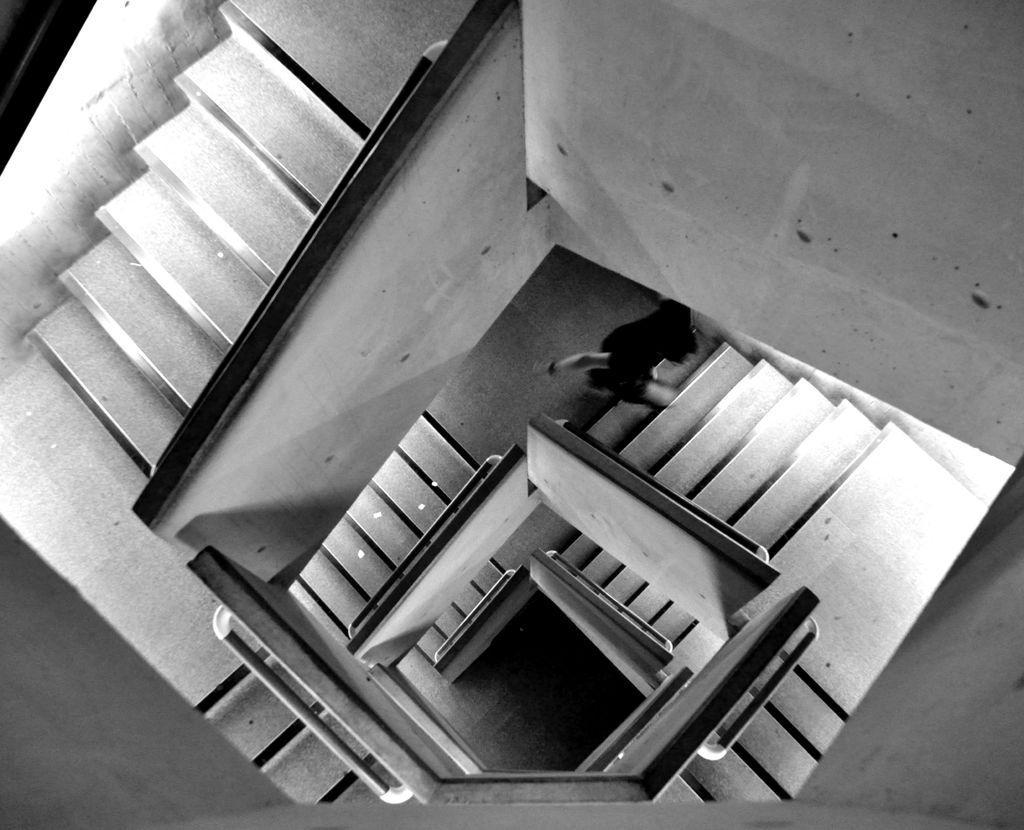Could you give a brief overview of what you see in this image? In this picture I can see a person and stairs. This picture is black and white in color. 